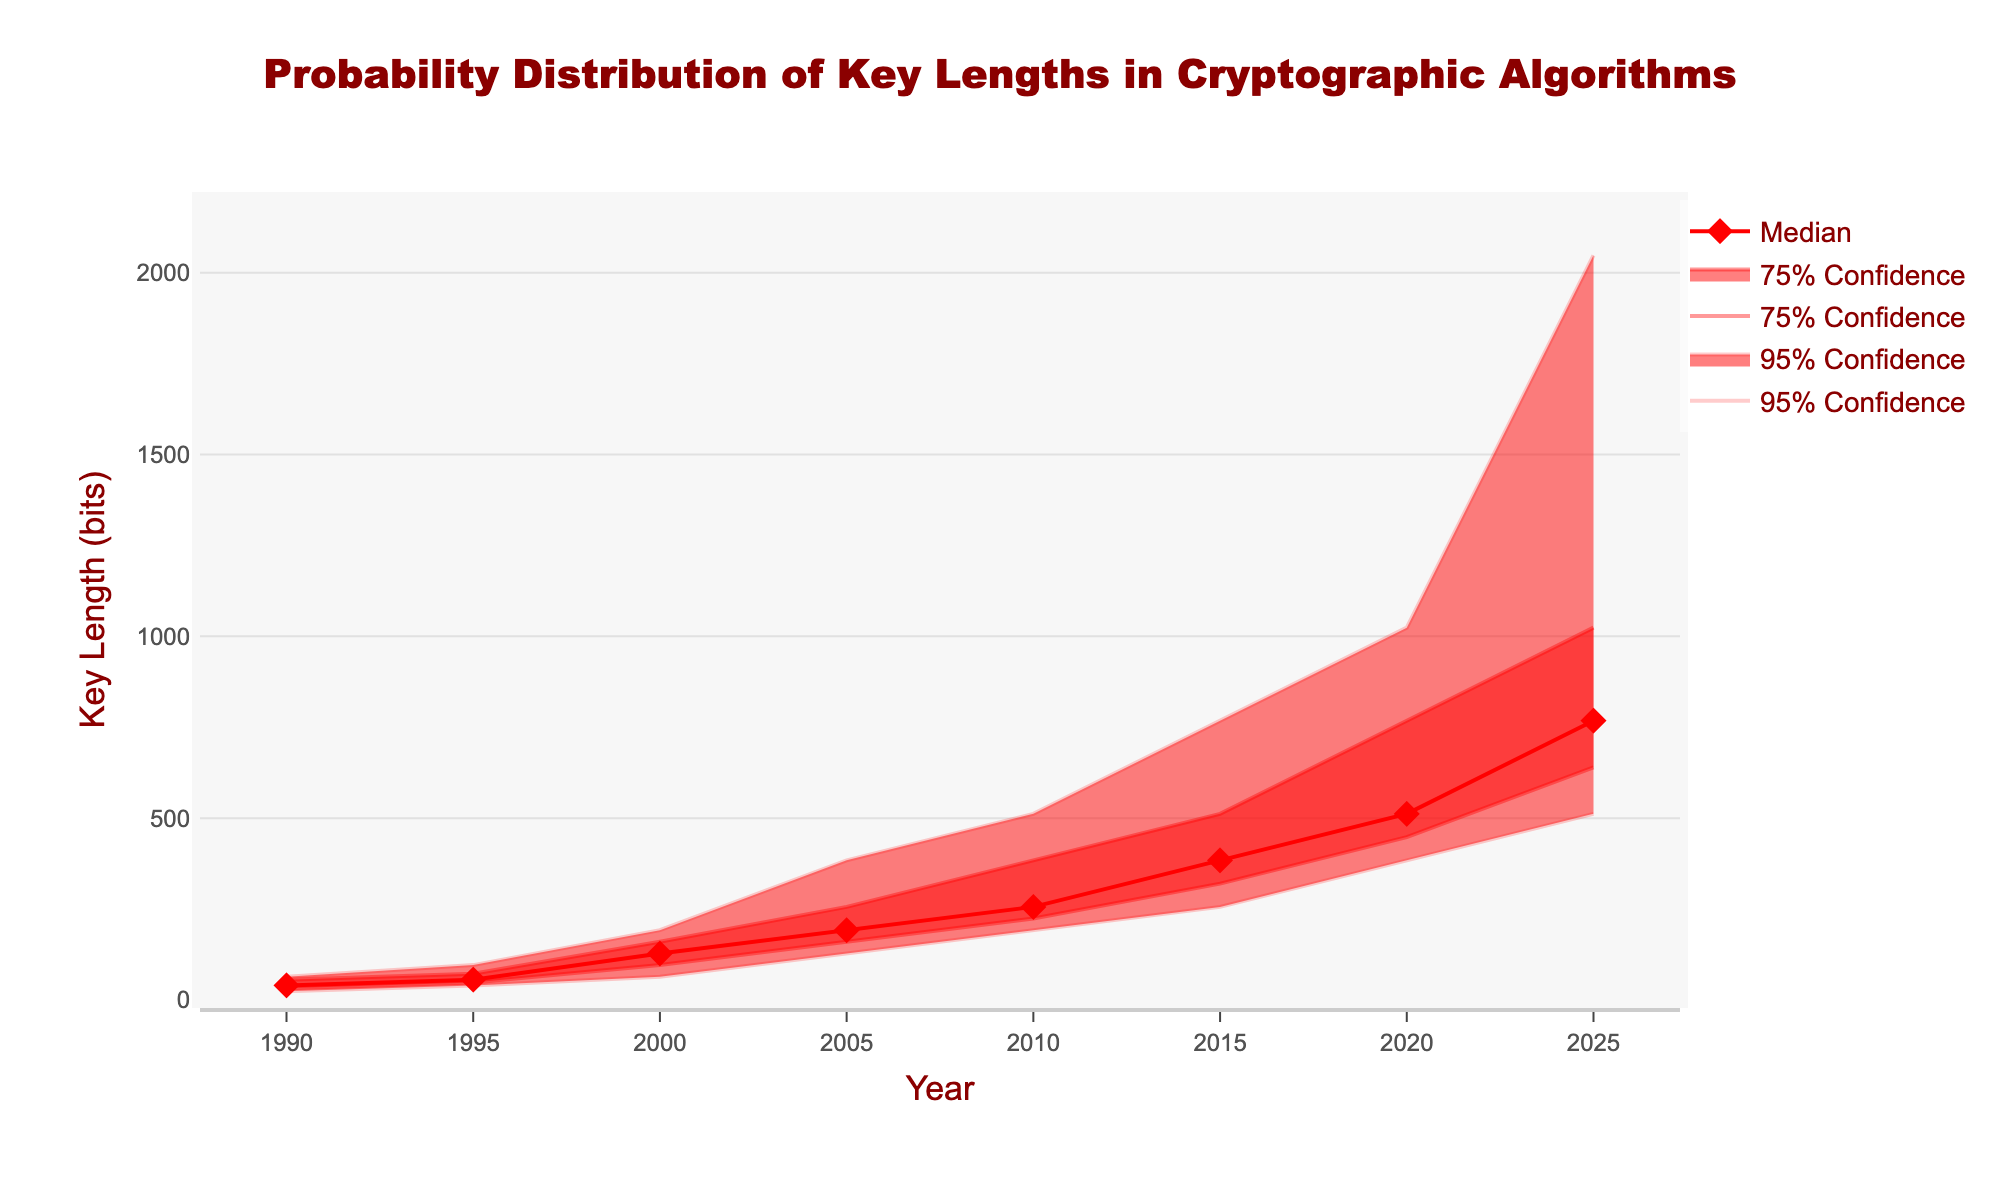What is the title of the figure? The title is usually located at the top center of the figure. Here it reads "Probability Distribution of Key Lengths in Cryptographic Algorithms".
Answer: Probability Distribution of Key Lengths in Cryptographic Algorithms What is the median key length in the year 2010? To find the median key length in the year 2010, look for the intersection of the "Median" line with the vertical line at 2010.
Answer: 256 bits How does the key length with 75% confidence interval in the year 2000 compare to the year 2005? The 75% confidence interval for the year 2000 is between 96 and 160 bits, while for 2005 it is between 160 and 256 bits. Comparing these ranges, the 2005 interval is higher.
Answer: The 2005 interval is higher What is the trend of the median key length from 1990 to 2025? To identify the trend, observe the median key length values over the years. It starts from 40 bits in 1990, steadily increases to 768 bits in 2025. This indicates a rising trend.
Answer: Rising trend Which year shows a key length with a lower 95% confidence interval of 192 bits? Locate the line that represents the lower 95% confidence interval and find where it reaches 192 bits. This occurs in the year 2010.
Answer: 2010 What is the range of key lengths with 95% confidence in the year 2025? To find the range, locate the lower and upper 95% confidence interval values for the year 2025. They are 512 bits and 2048 bits respectively. The range is 2048 - 512 bits.
Answer: 1536 bits Compare the median key length in 1990 and 2020. In 1990, the median key length is 40 bits, and in 2020, it is 512 bits. Comparing these two values, the key length in 2020 is significantly higher.
Answer: Key length in 2020 is significantly higher How does the upper 75% confidence level change from 2015 to 2020? Locate the upper 75% confidence level values for these years. It is 512 bits in 2015 and 768 bits in 2020, indicating an increase.
Answer: Increase During which year does the median first exceed 100 bits? Track the median key length values year by year until it first exceeds 100 bits. It happens in the year 2000.
Answer: 2000 What is the visual appearance of the 95% confidence interval area? The 95% confidence interval area is shaded in a light red color. It encompasses the space between the upper and lower 95% lines.
Answer: Light red shaded area 